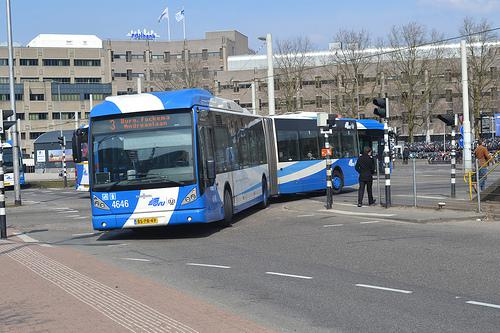Question: what color is the bus?
Choices:
A. Green and Red.
B. Blue.
C. Blue and white.
D. Red.
Answer with the letter. Answer: C Question: where was the photo taken?
Choices:
A. At a home.
B. At an intersection.
C. At a school.
D. At a library.
Answer with the letter. Answer: B Question: what number is on the lower left side of the bus?
Choices:
A. 6478.
B. 368.
C. 2686.
D. 4646.
Answer with the letter. Answer: D 